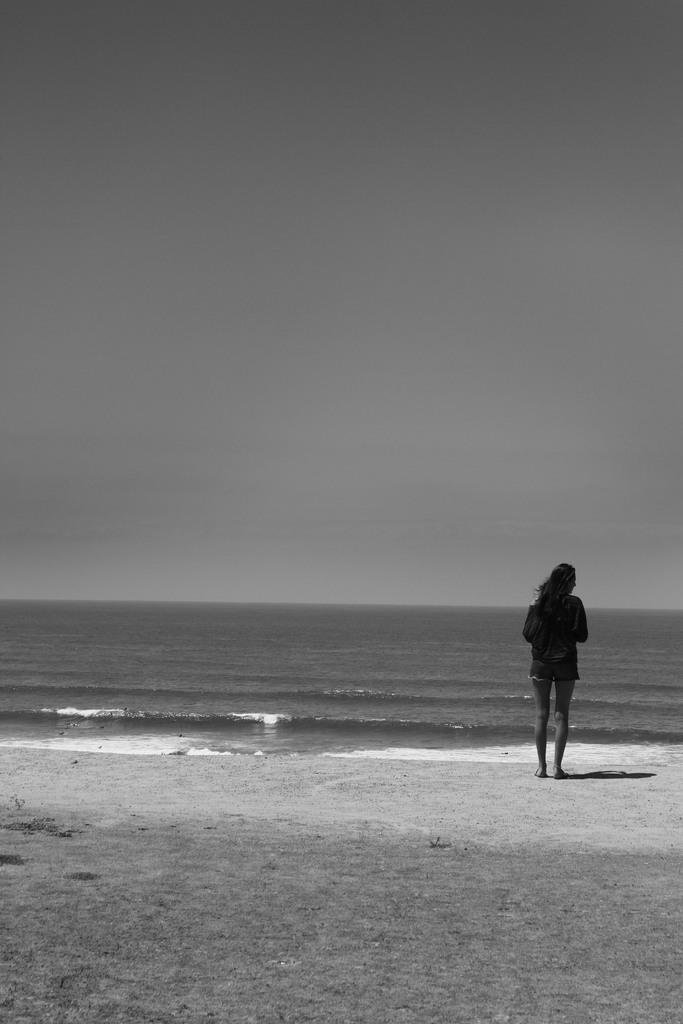Please provide a concise description of this image. In the picture we can see a sand surface on it we can see a woman standing and in front of her we can see water and sky. 